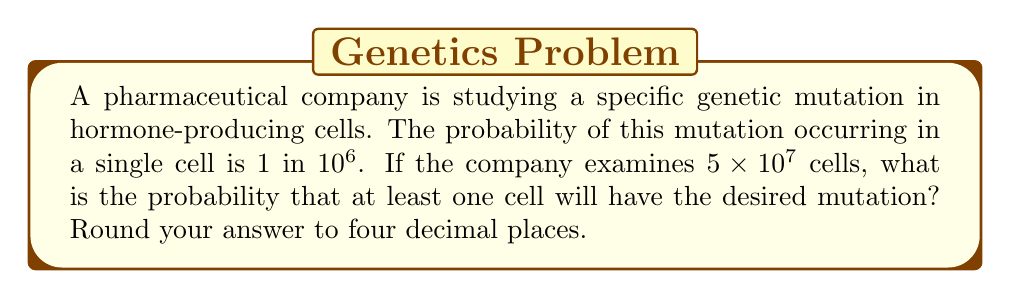Can you answer this question? Let's approach this step-by-step:

1) First, let's define our events:
   Let A be the event that a cell has the mutation.
   
2) We're given that $P(A) = \frac{1}{10^6} = 10^{-6}$

3) We want to find the probability of at least one cell having the mutation in $5 \times 10^7$ cells. It's easier to calculate the probability of no cells having the mutation and then subtract from 1.

4) The probability of a cell not having the mutation is:
   $P(\text{not A}) = 1 - P(A) = 1 - 10^{-6} = 0.999999$

5) For all $5 \times 10^7$ cells to not have the mutation, this needs to happen independently for each cell. So we raise this probability to the power of $5 \times 10^7$:

   $P(\text{no mutations}) = (0.999999)^{5 \times 10^7}$

6) We can simplify this using the properties of exponents:

   $P(\text{no mutations}) = ((1 - 10^{-6})^{10^6})^{50}$

7) Using the approximation $(1-x)^n \approx e^{-nx}$ for small $x$:

   $P(\text{no mutations}) \approx (e^{-1})^{50} = e^{-50} \approx 1.9287 \times 10^{-22}$

8) Therefore, the probability of at least one mutation is:

   $P(\text{at least one mutation}) = 1 - P(\text{no mutations}) = 1 - 1.9287 \times 10^{-22} \approx 0.9999999999999999999998071$

9) Rounding to four decimal places:

   $P(\text{at least one mutation}) \approx 1.0000$
Answer: $1.0000$ 